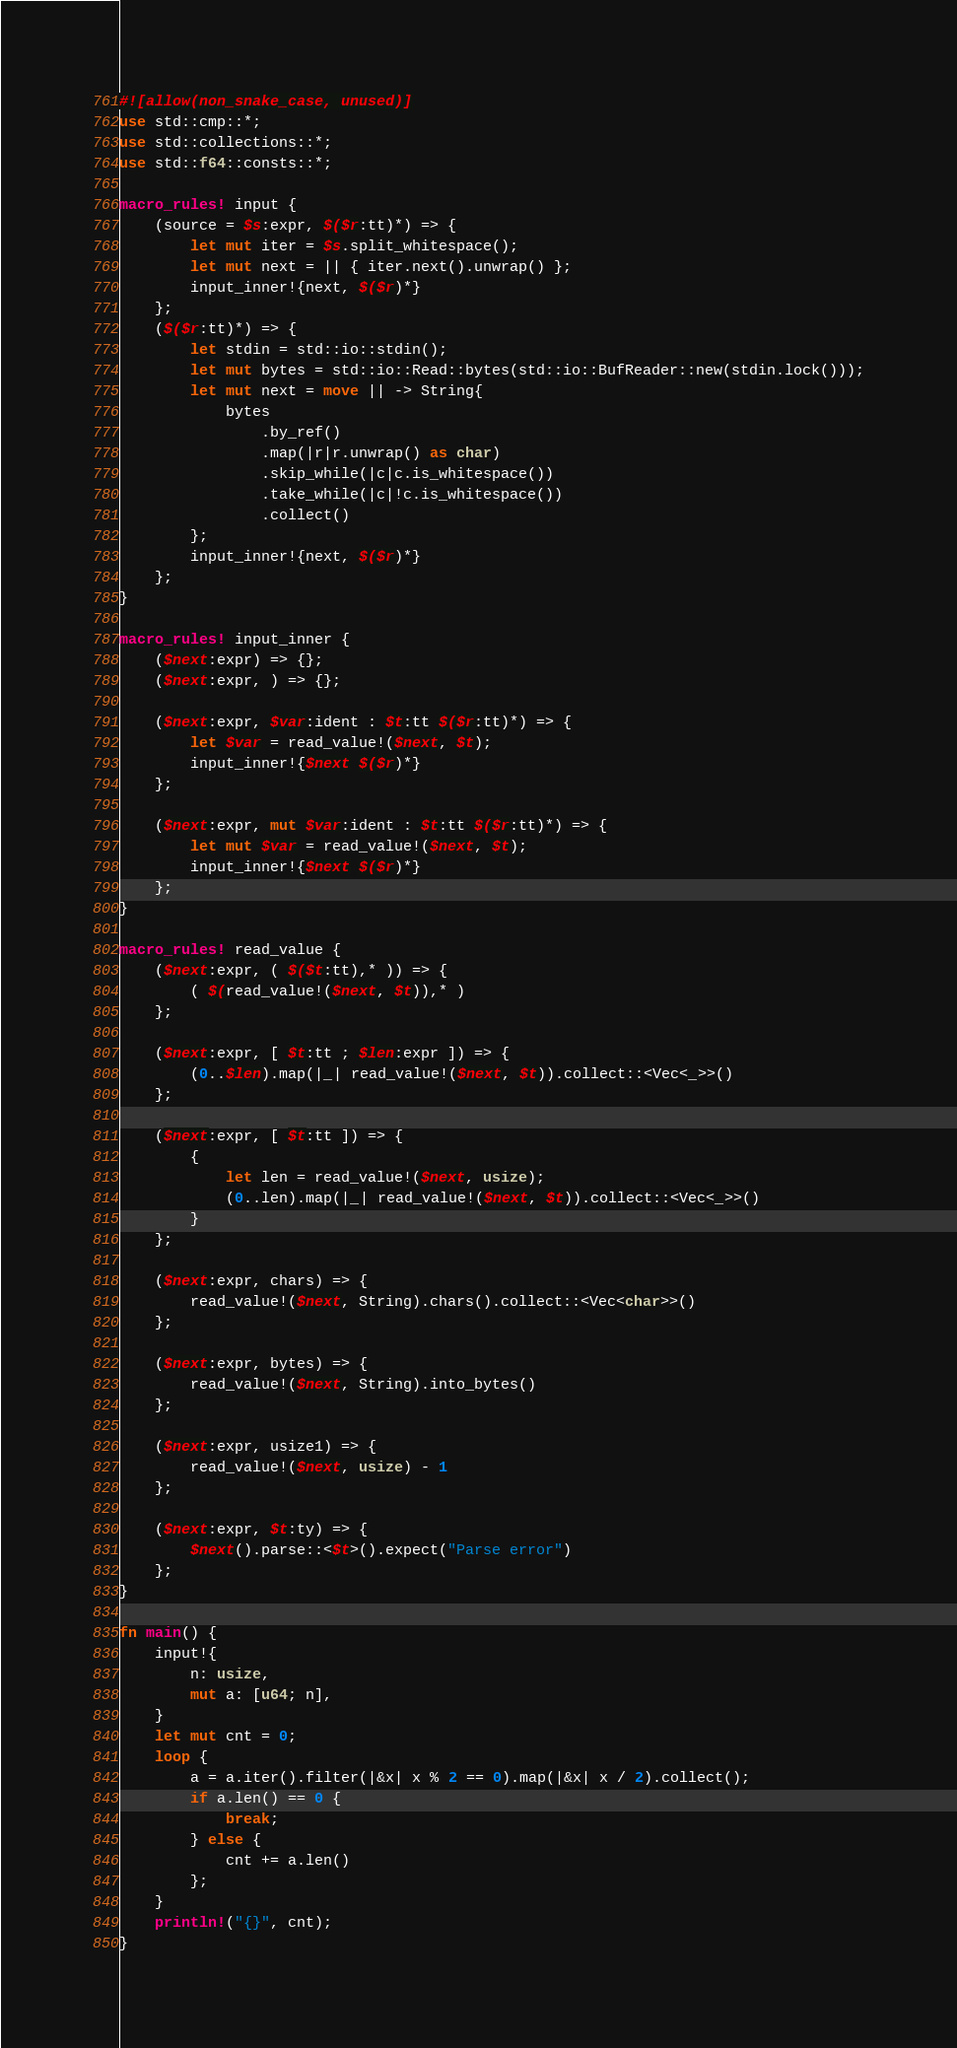<code> <loc_0><loc_0><loc_500><loc_500><_Rust_>#![allow(non_snake_case, unused)]
use std::cmp::*;
use std::collections::*;
use std::f64::consts::*;

macro_rules! input {
    (source = $s:expr, $($r:tt)*) => {
        let mut iter = $s.split_whitespace();
        let mut next = || { iter.next().unwrap() };
        input_inner!{next, $($r)*}
    };
    ($($r:tt)*) => {
        let stdin = std::io::stdin();
        let mut bytes = std::io::Read::bytes(std::io::BufReader::new(stdin.lock()));
        let mut next = move || -> String{
            bytes
                .by_ref()
                .map(|r|r.unwrap() as char)
                .skip_while(|c|c.is_whitespace())
                .take_while(|c|!c.is_whitespace())
                .collect()
        };
        input_inner!{next, $($r)*}
    };
}

macro_rules! input_inner {
    ($next:expr) => {};
    ($next:expr, ) => {};

    ($next:expr, $var:ident : $t:tt $($r:tt)*) => {
        let $var = read_value!($next, $t);
        input_inner!{$next $($r)*}
    };

    ($next:expr, mut $var:ident : $t:tt $($r:tt)*) => {
        let mut $var = read_value!($next, $t);
        input_inner!{$next $($r)*}
    };
}

macro_rules! read_value {
    ($next:expr, ( $($t:tt),* )) => {
        ( $(read_value!($next, $t)),* )
    };

    ($next:expr, [ $t:tt ; $len:expr ]) => {
        (0..$len).map(|_| read_value!($next, $t)).collect::<Vec<_>>()
    };

    ($next:expr, [ $t:tt ]) => {
        {
            let len = read_value!($next, usize);
            (0..len).map(|_| read_value!($next, $t)).collect::<Vec<_>>()
        }
    };

    ($next:expr, chars) => {
        read_value!($next, String).chars().collect::<Vec<char>>()
    };

    ($next:expr, bytes) => {
        read_value!($next, String).into_bytes()
    };

    ($next:expr, usize1) => {
        read_value!($next, usize) - 1
    };

    ($next:expr, $t:ty) => {
        $next().parse::<$t>().expect("Parse error")
    };
}

fn main() {
    input!{
        n: usize,
        mut a: [u64; n],
    }
    let mut cnt = 0;
    loop {
        a = a.iter().filter(|&x| x % 2 == 0).map(|&x| x / 2).collect();
        if a.len() == 0 {
            break;
        } else {
            cnt += a.len()
        };
    }
    println!("{}", cnt);
}
</code> 